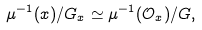Convert formula to latex. <formula><loc_0><loc_0><loc_500><loc_500>\mu ^ { - 1 } ( x ) / G _ { x } \simeq \mu ^ { - 1 } ( \mathcal { O } _ { x } ) / G ,</formula> 